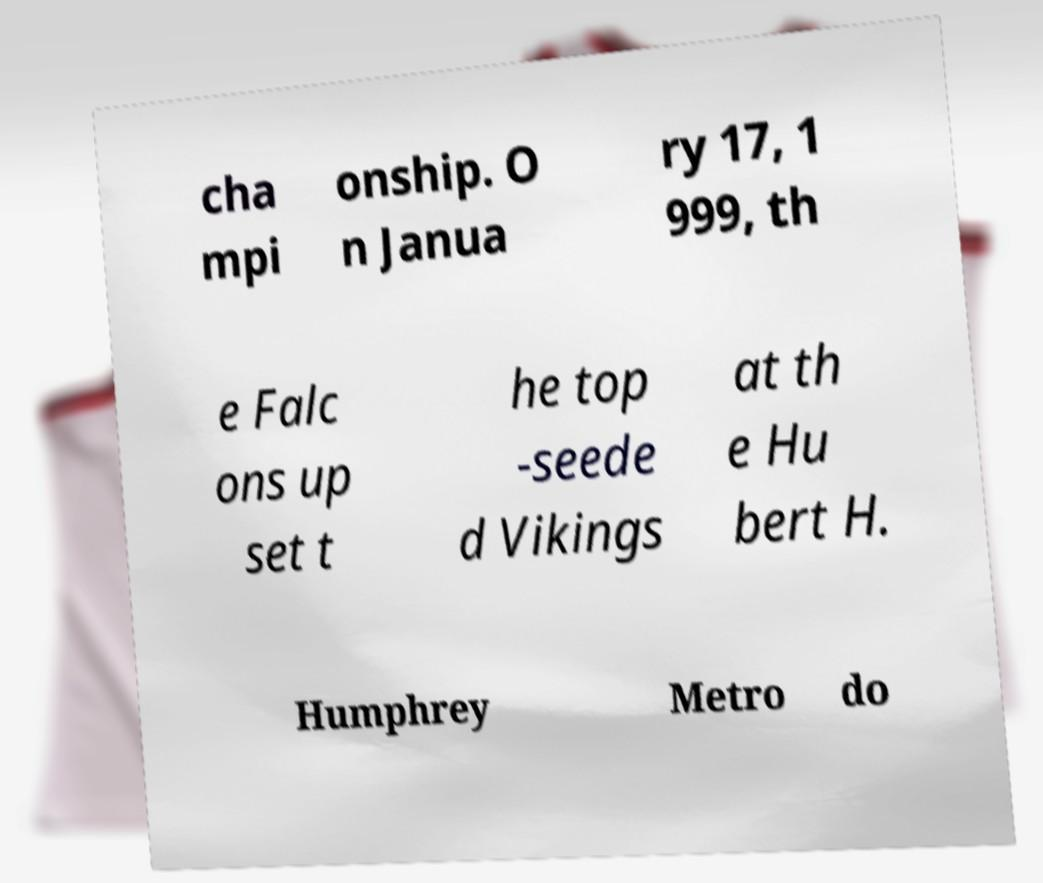Could you assist in decoding the text presented in this image and type it out clearly? cha mpi onship. O n Janua ry 17, 1 999, th e Falc ons up set t he top -seede d Vikings at th e Hu bert H. Humphrey Metro do 